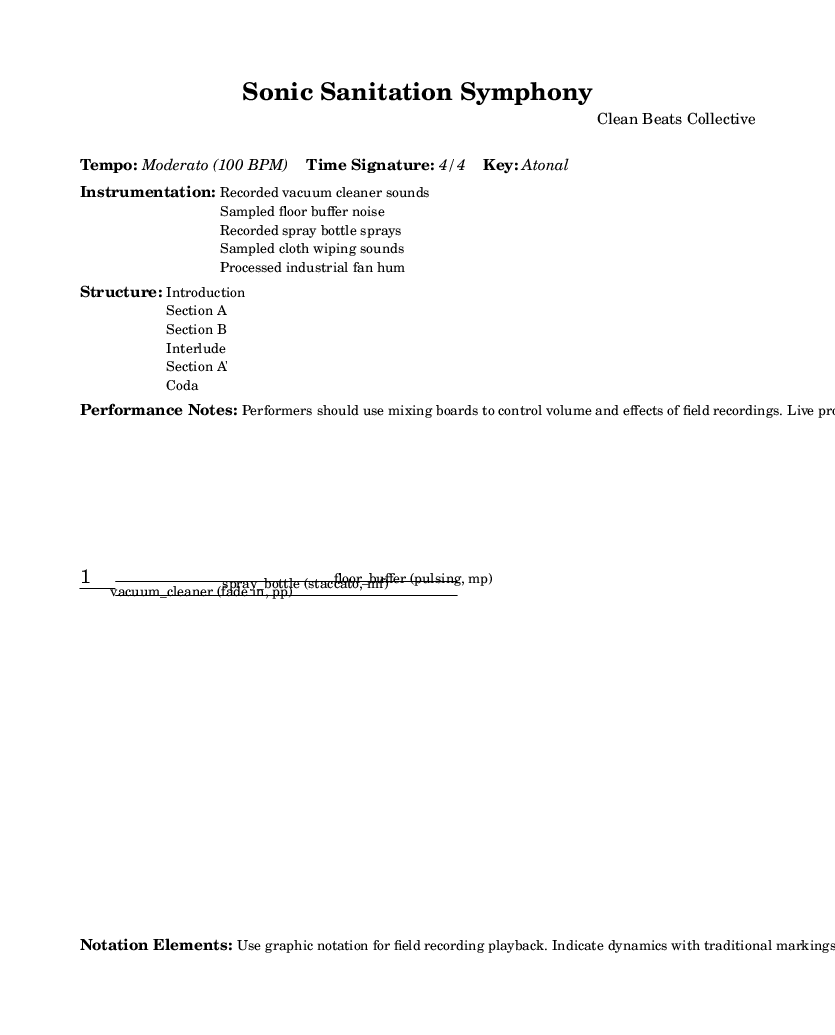What is the tempo of this piece? The tempo is indicated as "Moderato (100 BPM)." This information is typically found in the performance notes or markings at the beginning of the score.
Answer: Moderato (100 BPM) What is the time signature of this piece? The time signature is marked as "4/4." This can usually be found alongside the tempo marking or in the top section of the score where basic information about the piece is provided.
Answer: 4/4 How many sections are there in the structure? The structure lists six distinct parts: "Introduction," "Section A," "Section B," "Interlude," "Section A'," and "Coda." By counting the items in the structure section, we can ascertain the total number.
Answer: Six What types of sounds are used for the instrumentation? The instrumentation lists five elements: "Recorded vacuum cleaner sounds," "Sampled floor buffer noise," "Recorded spray bottle sprays," "Sampled cloth wiping sounds," and "Processed industrial fan hum." This information is located in the instrumentation section of the score.
Answer: Recorded vacuum cleaner sounds, Sampled floor buffer noise, Recorded spray bottle sprays, Sampled cloth wiping sounds, Processed industrial fan hum What dynamic marking is indicated for the vacuum cleaner sound? The vacuum cleaner sound is marked "fade in, pp," indicating a very soft dynamics (pianissimo) with a gradual increase in volume. This marking is explicitly stated alongside the notation for that sound in the score.
Answer: fade in, pp What notation elements are used in this piece for playing back field recordings? The piece utilizes "graphic notation" for playback of field recordings. This specification is provided in the notation elements section, emphasizing the unconventional approach typical of this type of experimental music.
Answer: graphic notation 